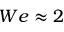<formula> <loc_0><loc_0><loc_500><loc_500>W e \approx 2</formula> 